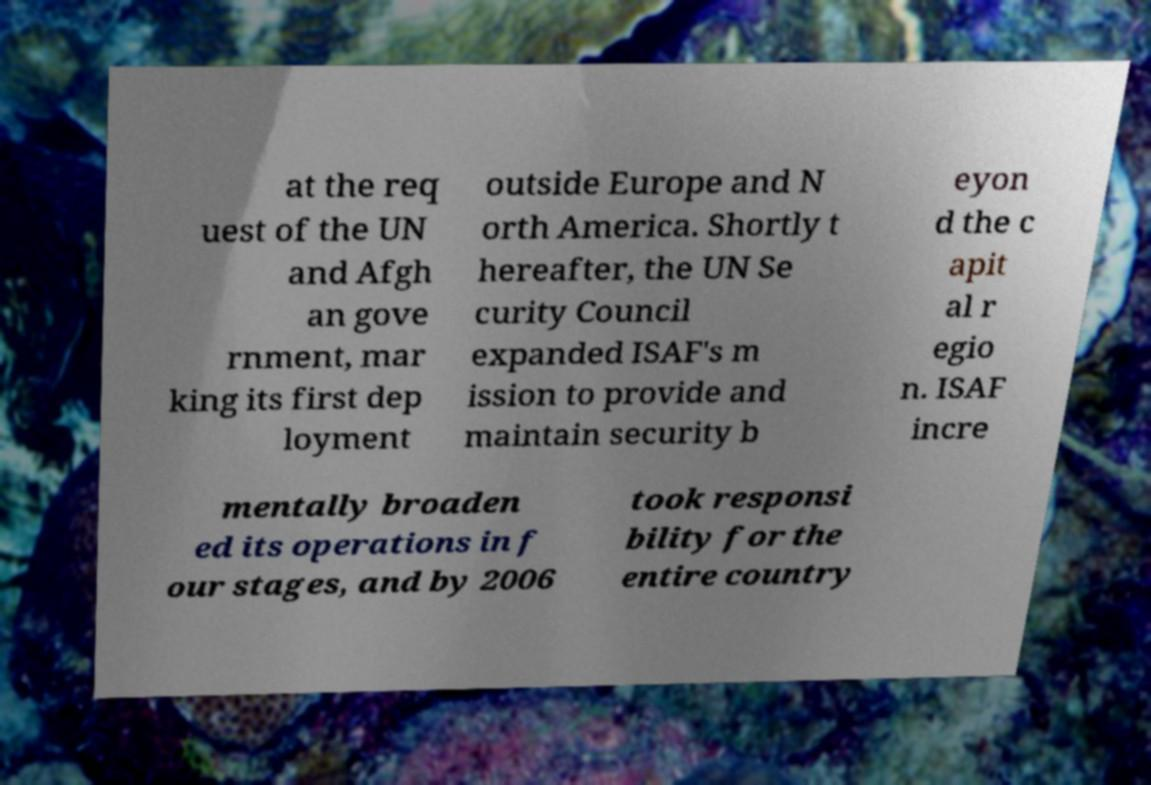Could you assist in decoding the text presented in this image and type it out clearly? at the req uest of the UN and Afgh an gove rnment, mar king its first dep loyment outside Europe and N orth America. Shortly t hereafter, the UN Se curity Council expanded ISAF's m ission to provide and maintain security b eyon d the c apit al r egio n. ISAF incre mentally broaden ed its operations in f our stages, and by 2006 took responsi bility for the entire country 